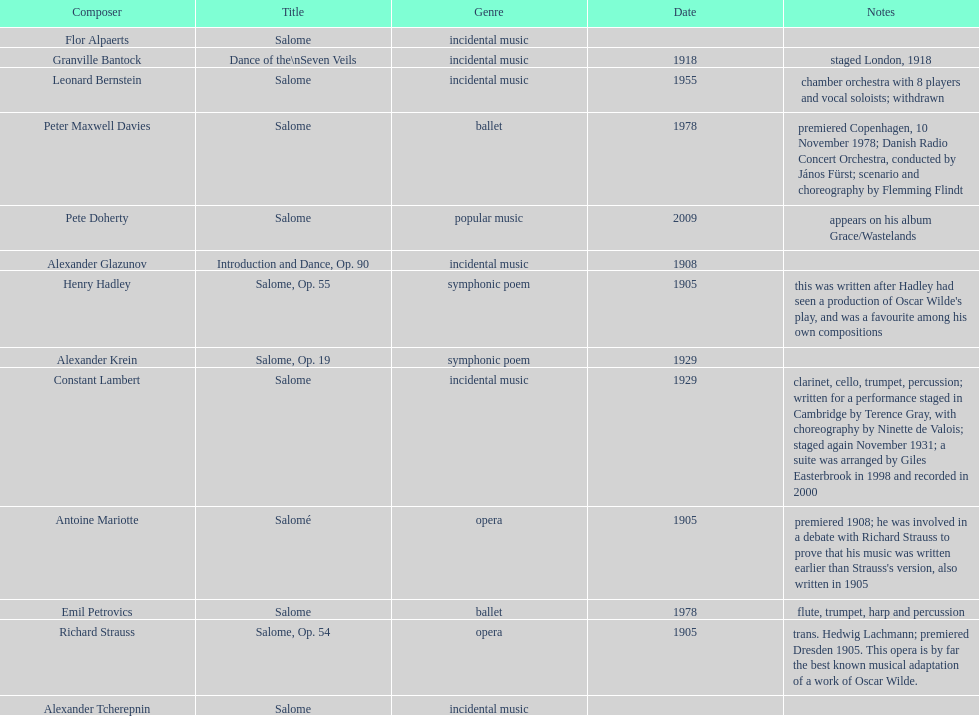Which musician can be found below pete doherty? Alexander Glazunov. 